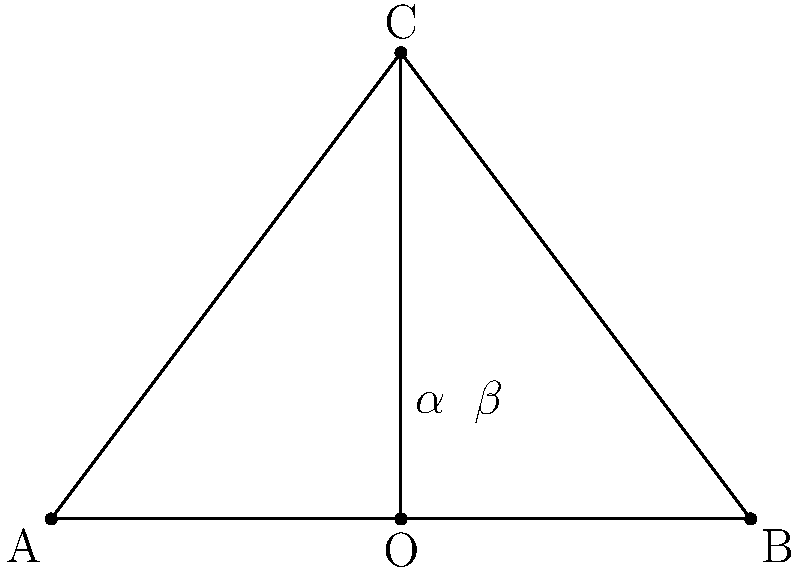In one of Kjell Boersma's animated sequences, multiple elements converge towards a central point to create focus. If two of these elements form an isosceles triangle ABC with the central point O on its base, and the angle of convergence (COA) is $\alpha$, what is the value of angle $\beta$ in terms of $\alpha$? Let's approach this step-by-step:

1) In an isosceles triangle, the base angles are equal. So, angle CAO = angle CBO.

2) The sum of angles in a triangle is always 180°. So in triangle ABC:
   $\angle CAB + \angle ABC + \angle BCA = 180°$

3) As O is on the base of the isosceles triangle, it bisects the base. So, AO = OB.

4) This means that triangles AOC and BOC are congruent.

5) In triangle AOC:
   $\alpha + \beta + \angle CAO = 90°$ (as these angles form a right angle)

6) We know that $\angle CAO = (180° - \angle ACB) / 2$ (half of the base angle of the isosceles triangle)

7) Substituting this into the equation from step 5:
   $\alpha + \beta + (180° - \angle ACB) / 2 = 90°$

8) From the properties of an isosceles triangle, we know that $\angle ACB = 180° - 2\alpha$

9) Substituting this:
   $\alpha + \beta + (180° - (180° - 2\alpha)) / 2 = 90°$
   $\alpha + \beta + \alpha = 90°$
   $2\alpha + \beta = 90°$

10) Solving for $\beta$:
    $\beta = 90° - 2\alpha$
Answer: $\beta = 90° - 2\alpha$ 